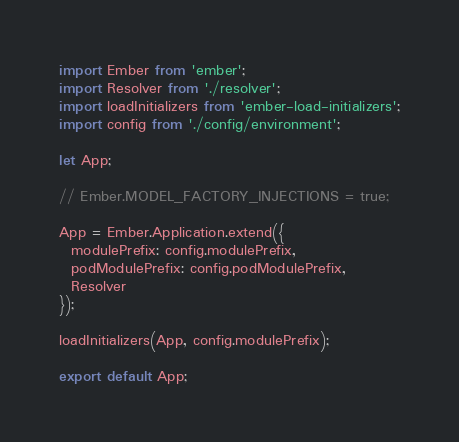<code> <loc_0><loc_0><loc_500><loc_500><_JavaScript_>import Ember from 'ember';
import Resolver from './resolver';
import loadInitializers from 'ember-load-initializers';
import config from './config/environment';

let App;

// Ember.MODEL_FACTORY_INJECTIONS = true;

App = Ember.Application.extend({
  modulePrefix: config.modulePrefix,
  podModulePrefix: config.podModulePrefix,
  Resolver
});

loadInitializers(App, config.modulePrefix);

export default App;
</code> 